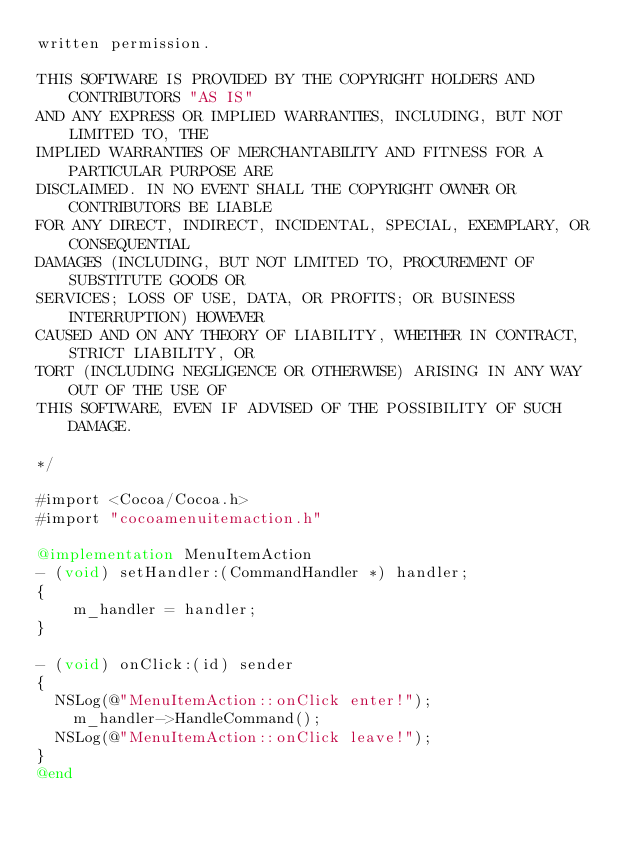<code> <loc_0><loc_0><loc_500><loc_500><_ObjectiveC_>written permission.

THIS SOFTWARE IS PROVIDED BY THE COPYRIGHT HOLDERS AND CONTRIBUTORS "AS IS"
AND ANY EXPRESS OR IMPLIED WARRANTIES, INCLUDING, BUT NOT LIMITED TO, THE 
IMPLIED WARRANTIES OF MERCHANTABILITY AND FITNESS FOR A PARTICULAR PURPOSE ARE
DISCLAIMED. IN NO EVENT SHALL THE COPYRIGHT OWNER OR CONTRIBUTORS BE LIABLE
FOR ANY DIRECT, INDIRECT, INCIDENTAL, SPECIAL, EXEMPLARY, OR CONSEQUENTIAL 
DAMAGES (INCLUDING, BUT NOT LIMITED TO, PROCUREMENT OF SUBSTITUTE GOODS OR 
SERVICES; LOSS OF USE, DATA, OR PROFITS; OR BUSINESS INTERRUPTION) HOWEVER 
CAUSED AND ON ANY THEORY OF LIABILITY, WHETHER IN CONTRACT, STRICT LIABILITY, OR 
TORT (INCLUDING NEGLIGENCE OR OTHERWISE) ARISING IN ANY WAY OUT OF THE USE OF 
THIS SOFTWARE, EVEN IF ADVISED OF THE POSSIBILITY OF SUCH DAMAGE.

*/

#import <Cocoa/Cocoa.h>
#import "cocoamenuitemaction.h"

@implementation MenuItemAction 
- (void) setHandler:(CommandHandler *) handler;
{
    m_handler = handler;
}

- (void) onClick:(id) sender
{
	NSLog(@"MenuItemAction::onClick enter!");
    m_handler->HandleCommand();
	NSLog(@"MenuItemAction::onClick leave!");
}
@end
</code> 